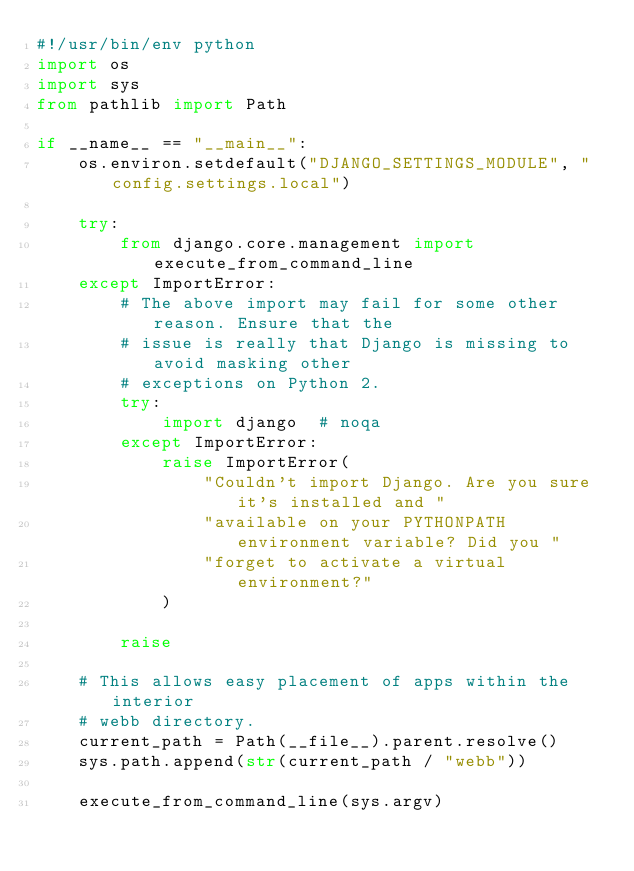Convert code to text. <code><loc_0><loc_0><loc_500><loc_500><_Python_>#!/usr/bin/env python
import os
import sys
from pathlib import Path

if __name__ == "__main__":
    os.environ.setdefault("DJANGO_SETTINGS_MODULE", "config.settings.local")

    try:
        from django.core.management import execute_from_command_line
    except ImportError:
        # The above import may fail for some other reason. Ensure that the
        # issue is really that Django is missing to avoid masking other
        # exceptions on Python 2.
        try:
            import django  # noqa
        except ImportError:
            raise ImportError(
                "Couldn't import Django. Are you sure it's installed and "
                "available on your PYTHONPATH environment variable? Did you "
                "forget to activate a virtual environment?"
            )

        raise

    # This allows easy placement of apps within the interior
    # webb directory.
    current_path = Path(__file__).parent.resolve()
    sys.path.append(str(current_path / "webb"))

    execute_from_command_line(sys.argv)
</code> 